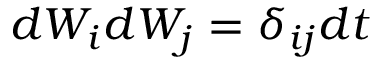<formula> <loc_0><loc_0><loc_500><loc_500>d W _ { i } d W _ { j } = \delta _ { i j } d t</formula> 